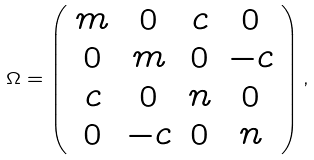<formula> <loc_0><loc_0><loc_500><loc_500>\Omega = \left ( \begin{array} { c c c c } m & 0 & c & 0 \\ 0 & m & 0 & - c \\ c & 0 & n & 0 \\ 0 & - c & 0 & n \\ \end{array} \right ) ,</formula> 